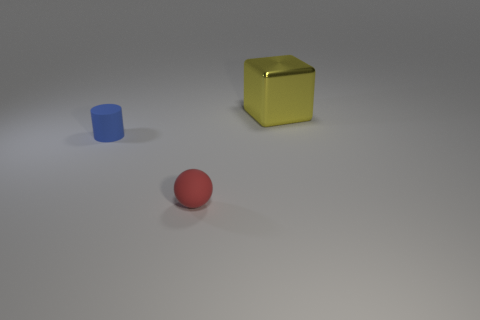Is there anything else that has the same size as the yellow object?
Provide a succinct answer. No. Is there anything else that is made of the same material as the big block?
Provide a short and direct response. No. Are there any other things that are the same color as the cylinder?
Your answer should be compact. No. How many other objects are there of the same size as the yellow metal block?
Keep it short and to the point. 0. How many balls are either small blue matte things or yellow things?
Provide a succinct answer. 0. Is the number of objects in front of the tiny cylinder greater than the number of tiny purple cubes?
Your response must be concise. Yes. The matte thing that is the same size as the blue rubber cylinder is what color?
Make the answer very short. Red. How many objects are either objects to the left of the yellow shiny object or metallic objects?
Keep it short and to the point. 3. What is the material of the thing to the left of the matte thing in front of the matte cylinder?
Offer a terse response. Rubber. Is there a small cylinder made of the same material as the big yellow cube?
Keep it short and to the point. No. 